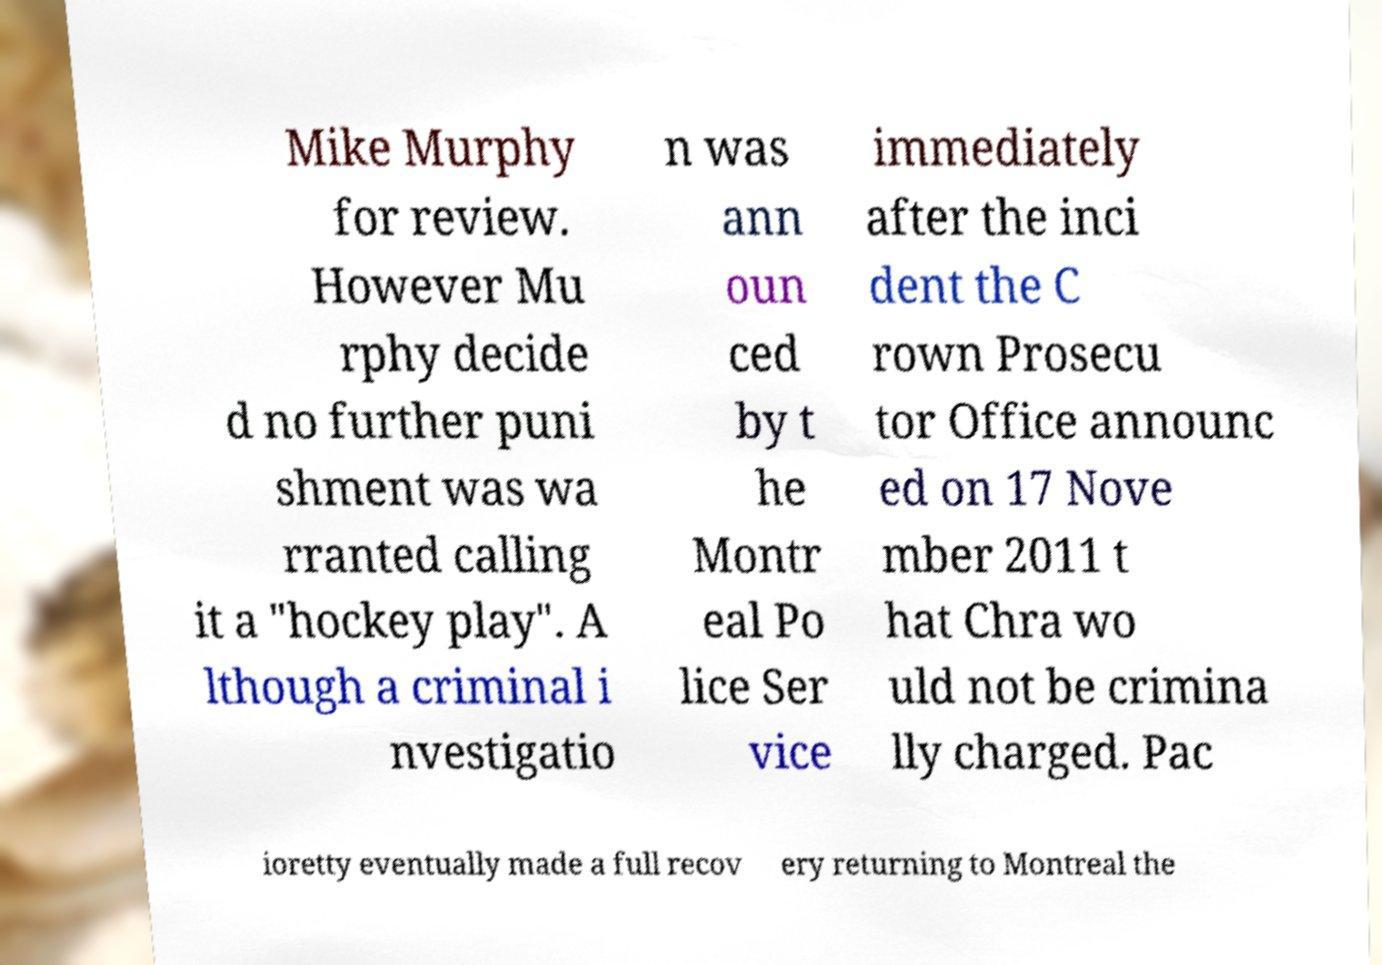There's text embedded in this image that I need extracted. Can you transcribe it verbatim? Mike Murphy for review. However Mu rphy decide d no further puni shment was wa rranted calling it a "hockey play". A lthough a criminal i nvestigatio n was ann oun ced by t he Montr eal Po lice Ser vice immediately after the inci dent the C rown Prosecu tor Office announc ed on 17 Nove mber 2011 t hat Chra wo uld not be crimina lly charged. Pac ioretty eventually made a full recov ery returning to Montreal the 